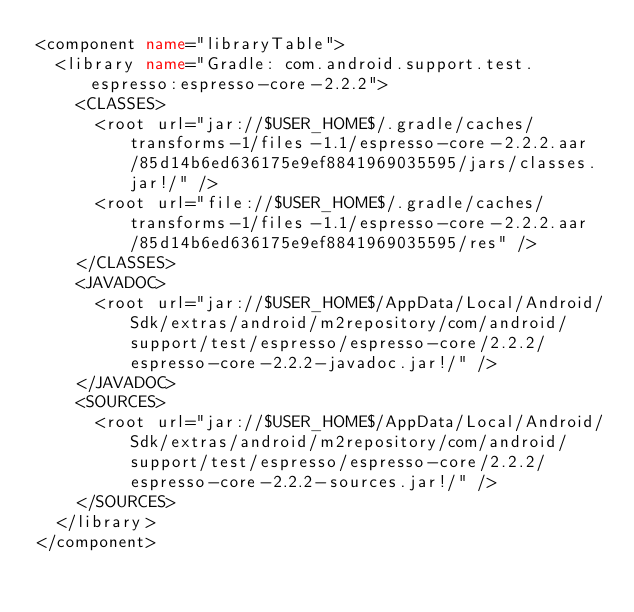Convert code to text. <code><loc_0><loc_0><loc_500><loc_500><_XML_><component name="libraryTable">
  <library name="Gradle: com.android.support.test.espresso:espresso-core-2.2.2">
    <CLASSES>
      <root url="jar://$USER_HOME$/.gradle/caches/transforms-1/files-1.1/espresso-core-2.2.2.aar/85d14b6ed636175e9ef8841969035595/jars/classes.jar!/" />
      <root url="file://$USER_HOME$/.gradle/caches/transforms-1/files-1.1/espresso-core-2.2.2.aar/85d14b6ed636175e9ef8841969035595/res" />
    </CLASSES>
    <JAVADOC>
      <root url="jar://$USER_HOME$/AppData/Local/Android/Sdk/extras/android/m2repository/com/android/support/test/espresso/espresso-core/2.2.2/espresso-core-2.2.2-javadoc.jar!/" />
    </JAVADOC>
    <SOURCES>
      <root url="jar://$USER_HOME$/AppData/Local/Android/Sdk/extras/android/m2repository/com/android/support/test/espresso/espresso-core/2.2.2/espresso-core-2.2.2-sources.jar!/" />
    </SOURCES>
  </library>
</component></code> 